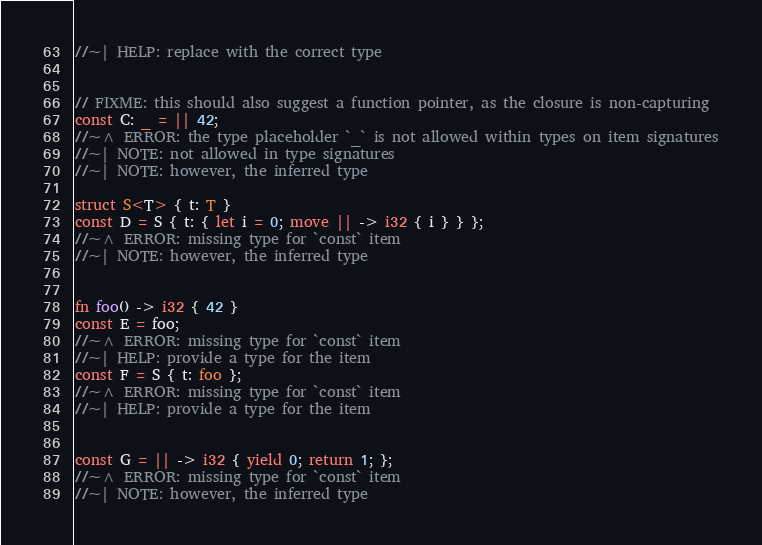<code> <loc_0><loc_0><loc_500><loc_500><_Rust_>//~| HELP: replace with the correct type


// FIXME: this should also suggest a function pointer, as the closure is non-capturing
const C: _ = || 42;
//~^ ERROR: the type placeholder `_` is not allowed within types on item signatures
//~| NOTE: not allowed in type signatures
//~| NOTE: however, the inferred type

struct S<T> { t: T }
const D = S { t: { let i = 0; move || -> i32 { i } } };
//~^ ERROR: missing type for `const` item
//~| NOTE: however, the inferred type


fn foo() -> i32 { 42 }
const E = foo;
//~^ ERROR: missing type for `const` item
//~| HELP: provide a type for the item
const F = S { t: foo };
//~^ ERROR: missing type for `const` item
//~| HELP: provide a type for the item


const G = || -> i32 { yield 0; return 1; };
//~^ ERROR: missing type for `const` item
//~| NOTE: however, the inferred type
</code> 